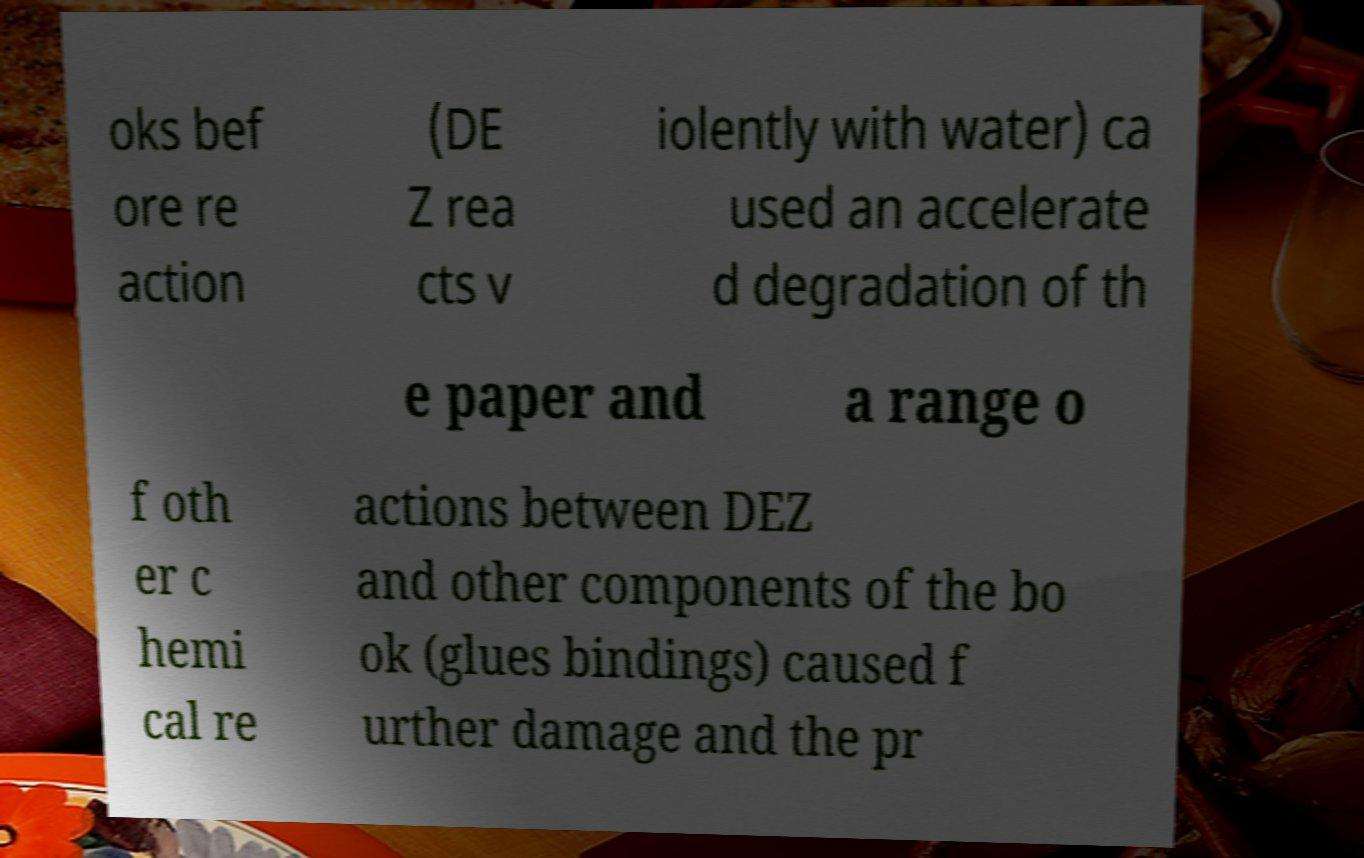Please read and relay the text visible in this image. What does it say? oks bef ore re action (DE Z rea cts v iolently with water) ca used an accelerate d degradation of th e paper and a range o f oth er c hemi cal re actions between DEZ and other components of the bo ok (glues bindings) caused f urther damage and the pr 